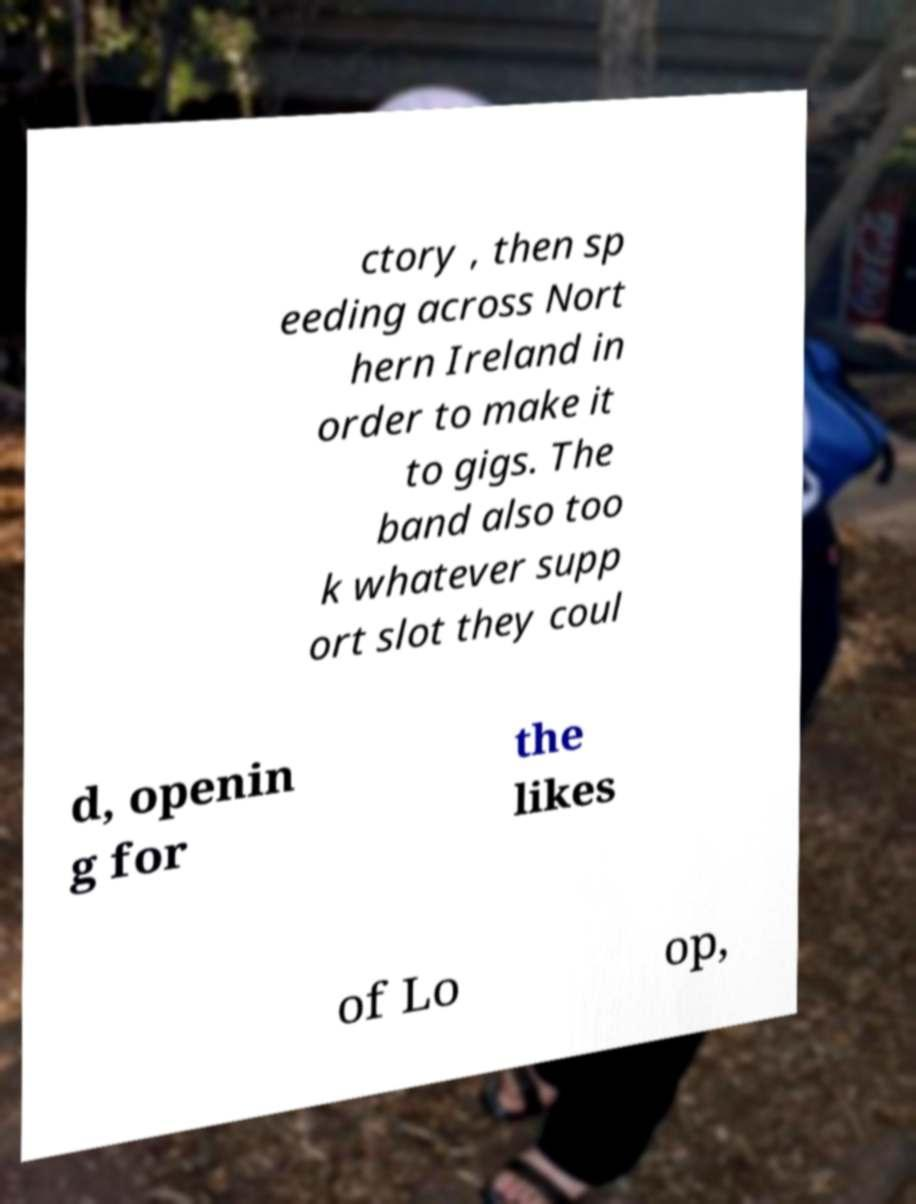For documentation purposes, I need the text within this image transcribed. Could you provide that? ctory , then sp eeding across Nort hern Ireland in order to make it to gigs. The band also too k whatever supp ort slot they coul d, openin g for the likes of Lo op, 